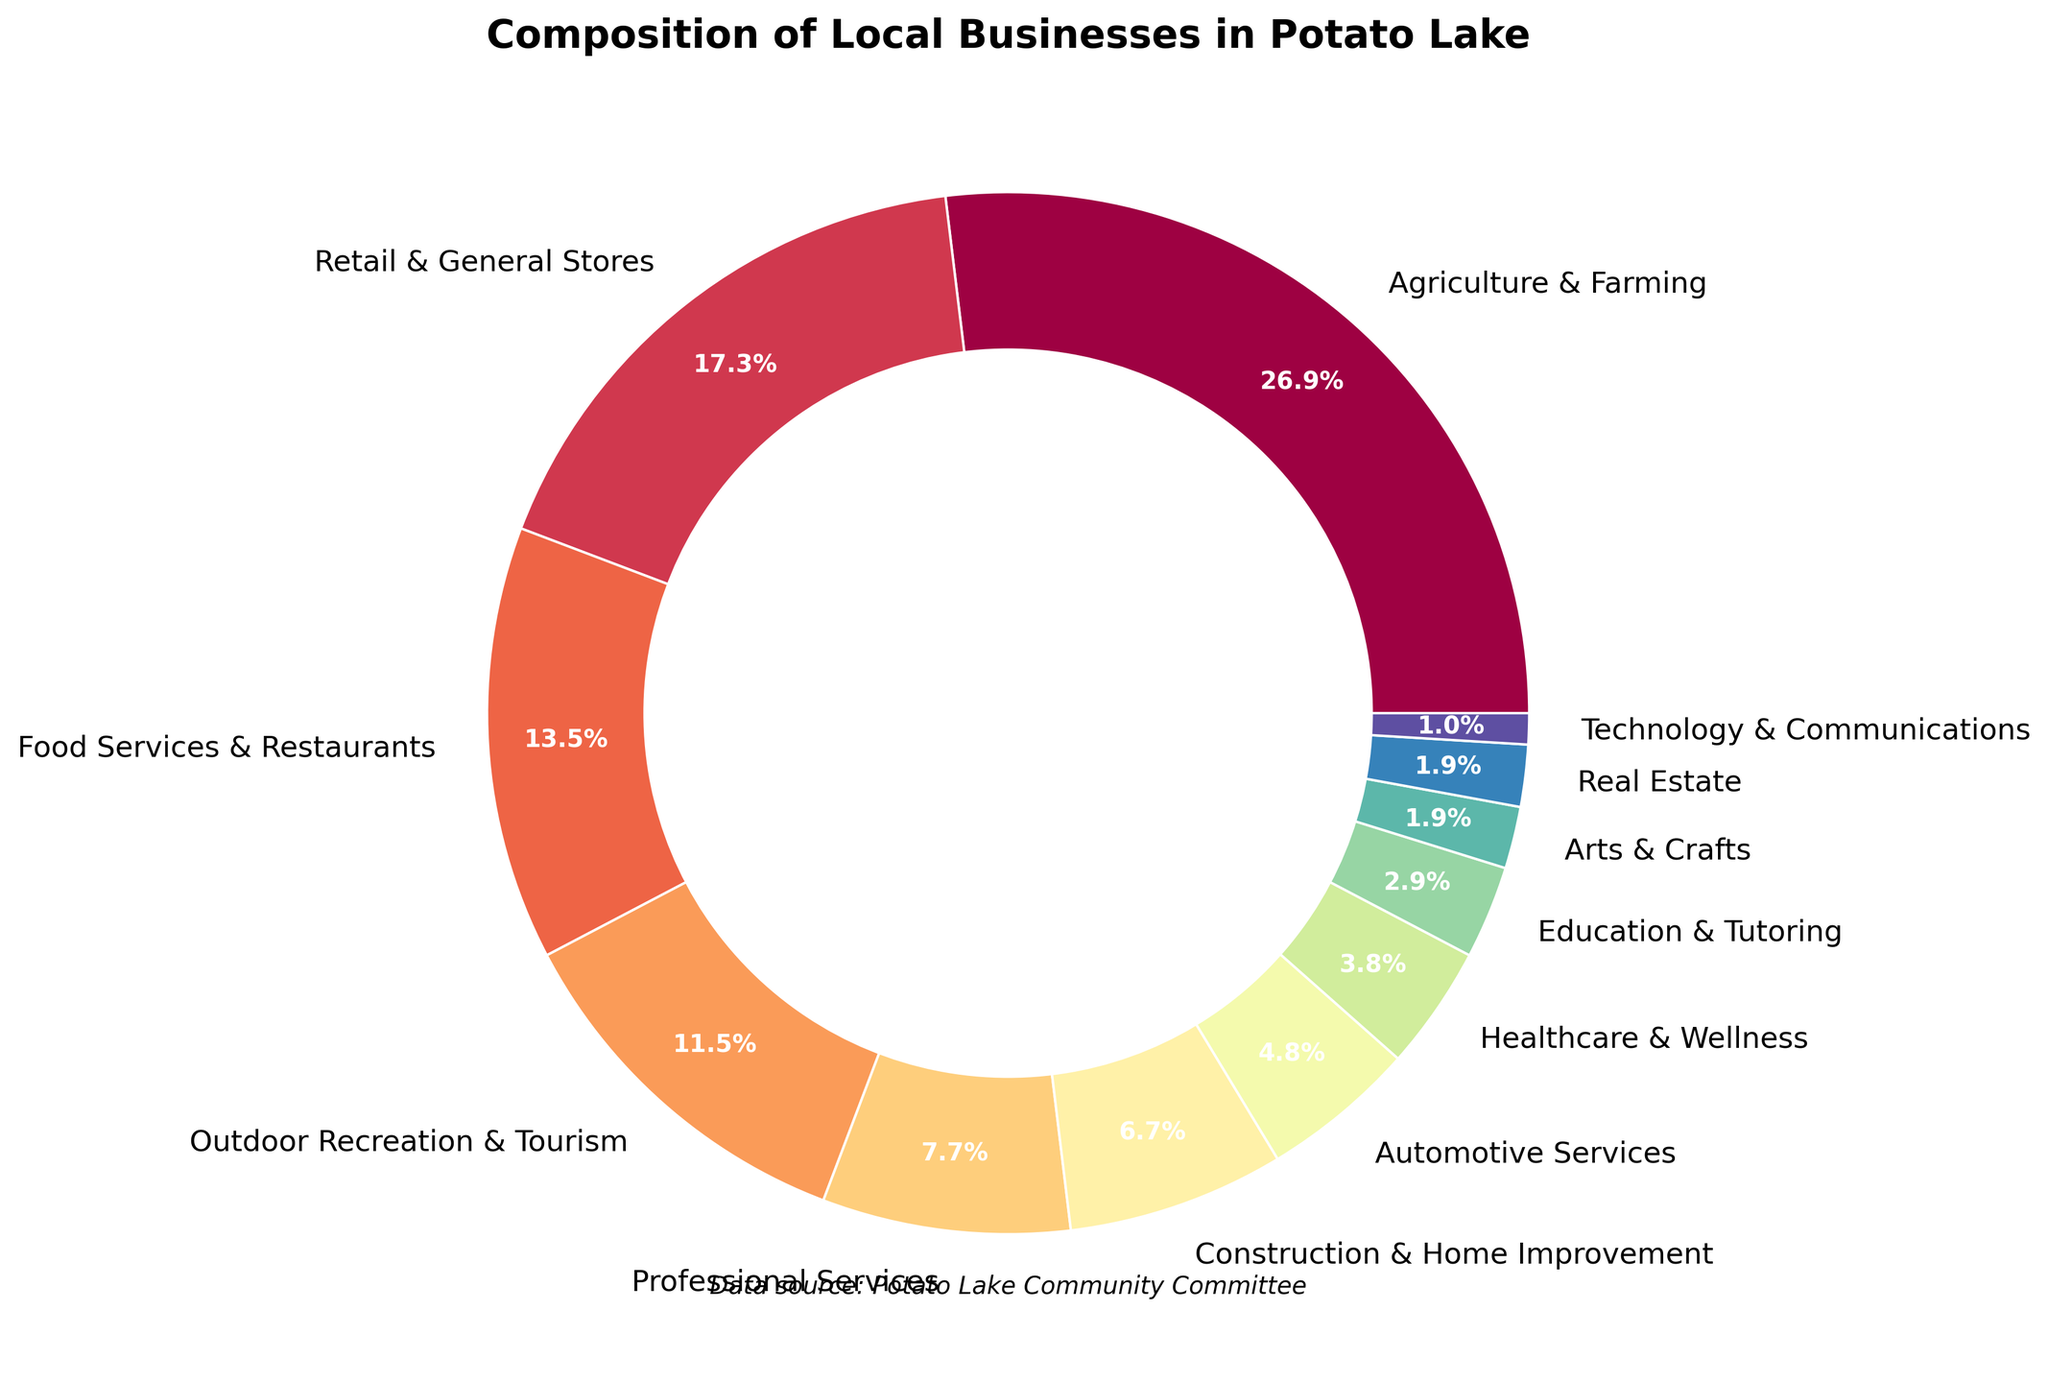What percentage of local businesses in Potato Lake are related to Agriculture & Farming? The pie chart shows that the slice representing Agriculture & Farming is labeled as 28%.
Answer: 28% Which type of business has a larger percentage: Retail & General Stores or Food Services & Restaurants? The pie chart shows that Retail & General Stores has a slice labeled as 18%, while Food Services & Restaurants has a slice labeled as 14%. Therefore, Retail & General Stores has a larger percentage.
Answer: Retail & General Stores What's the combined percentage of Outdoor Recreation & Tourism, and Healthcare & Wellness businesses? Look at the slices for Outdoor Recreation & Tourism (12%) and Healthcare & Wellness (4%). Add these percentages: 12% + 4% = 16%.
Answer: 16% Which three types of businesses have the smallest percentages? The pie chart shows that Technology & Communications, Arts & Crafts, and Real Estate each have the smallest percentages labeled as 1%, 2%, and 2% respectively.
Answer: Technology & Communications, Arts & Crafts, and Real Estate How much smaller is the percentage of Automotive Services compared to Agriculture & Farming? The pie chart shows Automotive Services at 5% and Agriculture & Farming at 28%. Subtract 5% from 28% to find the difference: 28% - 5% = 23%.
Answer: 23% Are the percentages of Food Services & Restaurants and Professional Services combined greater or smaller than the percentage of Agriculture & Farming alone? Food Services & Restaurants has a percentage of 14%, and Professional Services has a percentage of 8%. Add these two percentages: 14% + 8% = 22%. Agriculture & Farming alone is 28%, which is higher than 22%.
Answer: Smaller How does the percentage of Construction & Home Improvement compare to Professional Services? The pie chart shows that Construction & Home Improvement has a percentage of 7%, while Professional Services has a percentage of 8%. Therefore, Professional Services has a slightly larger percentage than Construction & Home Improvement.
Answer: Professional Services If we combine the percentage of Education & Tutoring with Arts & Crafts, what percentage do we get? Is it higher or lower than Automotive Services? Education & Tutoring is at 3% and Arts & Crafts is at 2%. Adding these gives 3% + 2% = 5%. Since Automotive Services is also at 5%, the combined percentage is equal.
Answer: Equal What is the largest non-Agriculture type of business by percentage? Excluding Agriculture & Farming, the largest business type is Retail & General Stores, which is labeled as 18%.
Answer: Retail & General Stores 